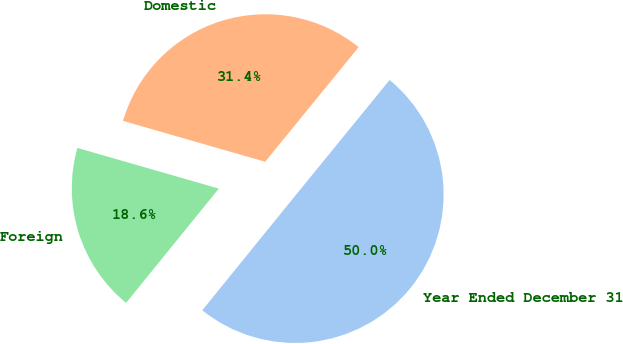<chart> <loc_0><loc_0><loc_500><loc_500><pie_chart><fcel>Year Ended December 31<fcel>Domestic<fcel>Foreign<nl><fcel>49.96%<fcel>31.43%<fcel>18.61%<nl></chart> 